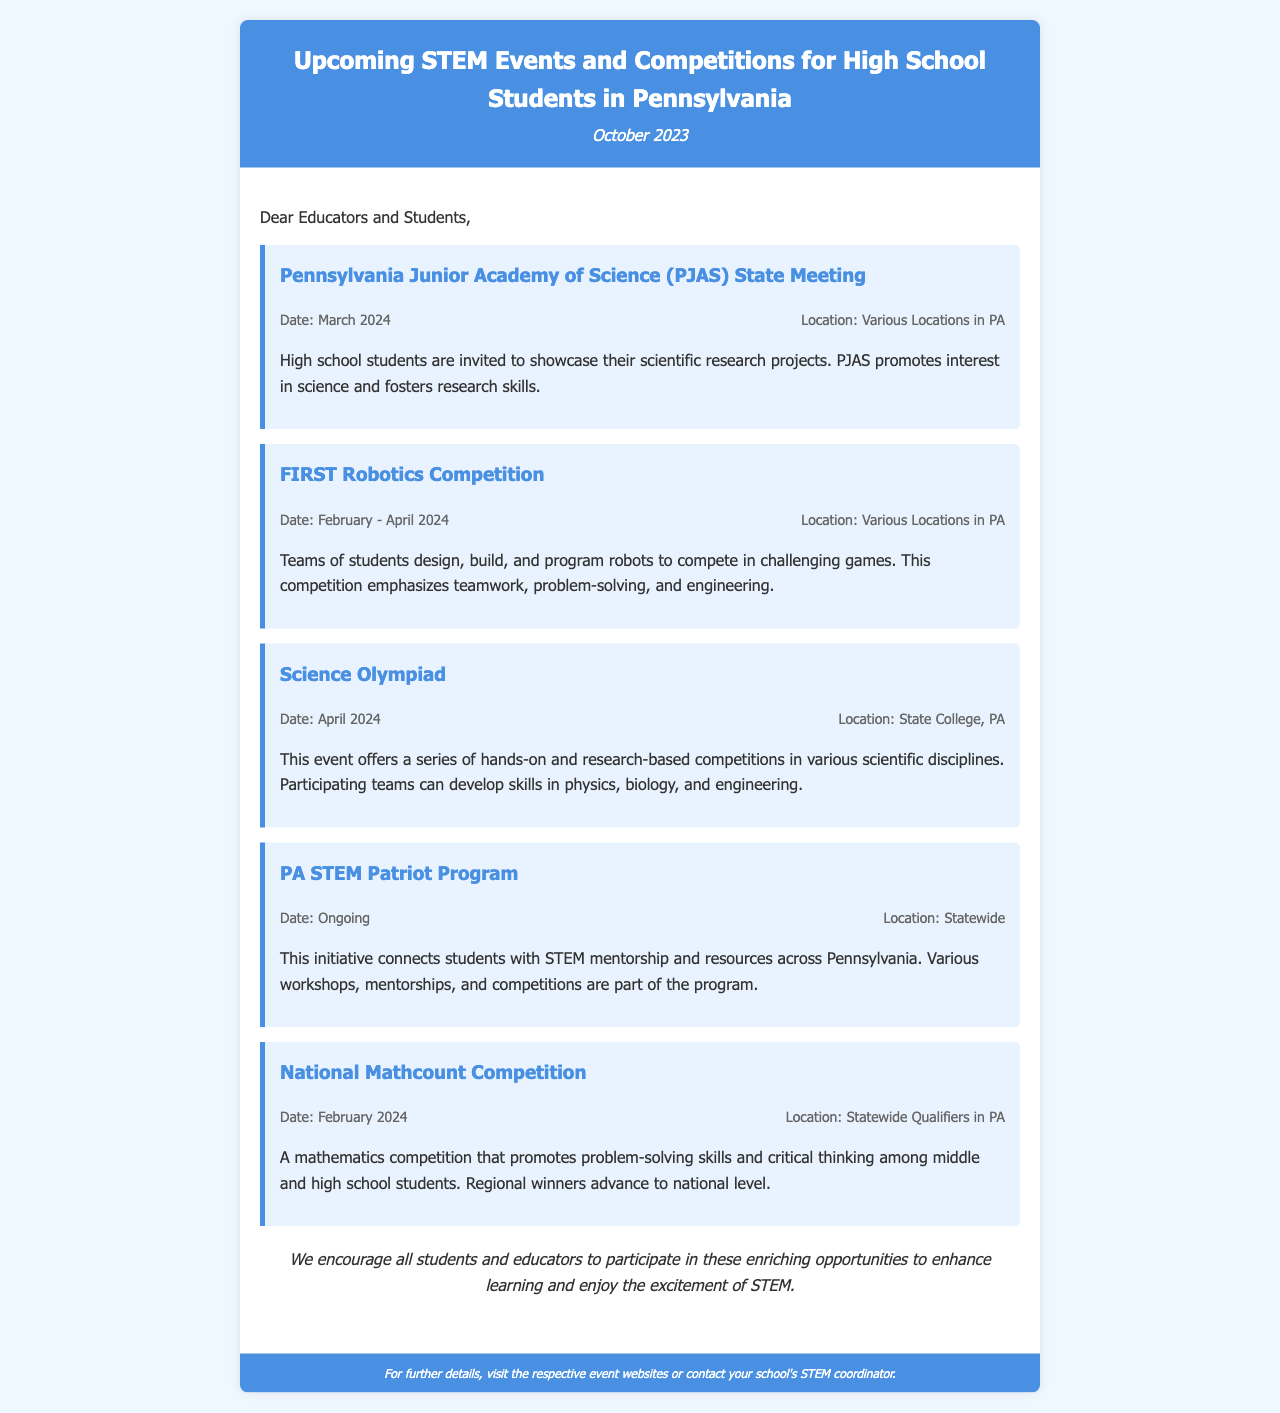What is the title of the newsletter? The title of the newsletter is mentioned at the top of the document, stating the focus on upcoming STEM events and competitions for high school students in Pennsylvania.
Answer: Upcoming STEM Events and Competitions for High School Students in Pennsylvania When is the Science Olympiad scheduled? The event details include the date for the Science Olympiad, which is clearly stated in the document.
Answer: April 2024 Where will the FIRST Robotics Competition take place? The document specifies that the locations for this competition are various locations throughout Pennsylvania.
Answer: Various Locations in PA What ongoing program connects students with STEM mentorship? The document describes an initiative that connects students with STEM resources and mentorship in Pennsylvania.
Answer: PA STEM Patriot Program How many events are listed in the newsletter? The document includes a list of specific STEM events, from which the total can be derived by counting them.
Answer: Five events What type of skills does the National Mathcount Competition promote? The document explains the goal of this mathematics competition, focusing on specific skills emphasized during the event.
Answer: Problem-solving skills and critical thinking What is the location for the Science Olympiad event? The document provides a specific location for the Science Olympiad, which can be directly located in the event details.
Answer: State College, PA What is the date range for the FIRST Robotics Competition? The event details mention the duration during which the FIRST Robotics Competition takes place.
Answer: February - April 2024 What type of competitions does the PA STEM Patriot Program include? The document specifies activities included in this program, hinting at the types of educational engagements available.
Answer: Workshops, mentorships, and competitions 